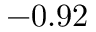<formula> <loc_0><loc_0><loc_500><loc_500>- 0 . 9 2</formula> 